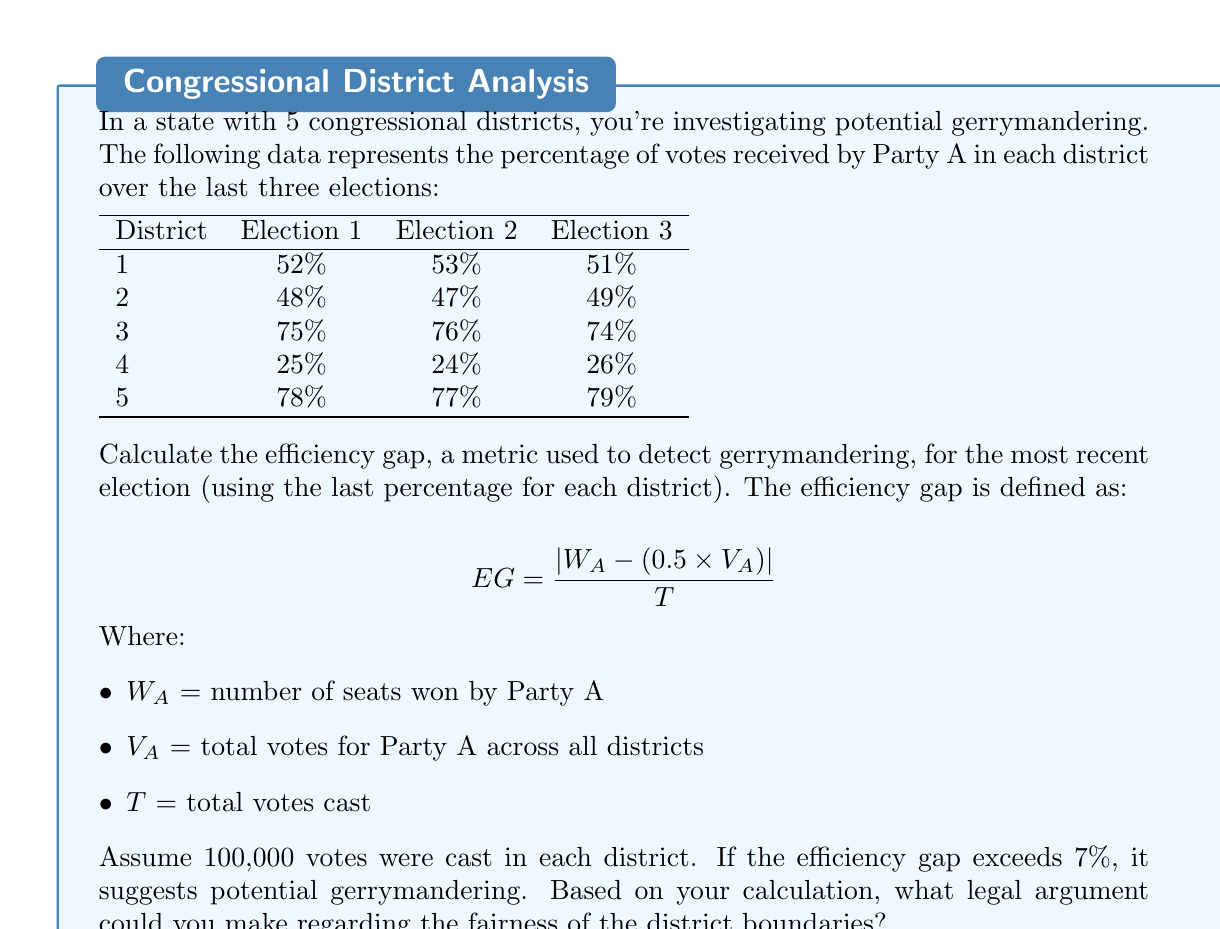Show me your answer to this math problem. Let's approach this step-by-step:

1) First, we need to calculate $W_A$ and $V_A$:

   $W_A$: Party A won 3 districts (1, 3, and 5) where they received > 50% of votes.
   
   $V_A$: Total votes for Party A = (51% + 49% + 74% + 26% + 79%) × 100,000
        = 279,000 votes

2) Calculate total votes cast:
   $T = 5 \times 100,000 = 500,000$ votes

3) Now we can plug these values into the efficiency gap formula:

   $$ EG = \frac{|W_A - (0.5 \times V_A)|}{T} $$
   
   $$ EG = \frac{|3 - (0.5 \times 279,000)|}{500,000} $$

4) Simplify:
   $$ EG = \frac{|3 - 139,500|}{500,000} = \frac{139,497}{500,000} = 0.278994 $$

5) Convert to percentage:
   $0.278994 \times 100\% = 27.8994\%$

6) Legal argument:
   The efficiency gap of 27.8994% significantly exceeds the 7% threshold, suggesting potential gerrymandering. This could be used to argue that the current district boundaries unfairly advantage Party A, potentially violating the principle of equal representation. A constitutional challenge could be mounted, arguing that these districts infringe on voters' rights to equal protection under the Fourteenth Amendment.
Answer: 27.8994%; exceeds threshold, suggests gerrymandering 